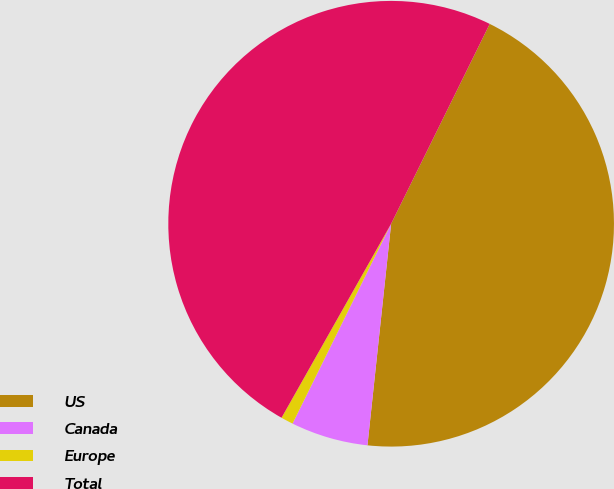Convert chart to OTSL. <chart><loc_0><loc_0><loc_500><loc_500><pie_chart><fcel>US<fcel>Canada<fcel>Europe<fcel>Total<nl><fcel>44.4%<fcel>5.6%<fcel>0.89%<fcel>49.11%<nl></chart> 